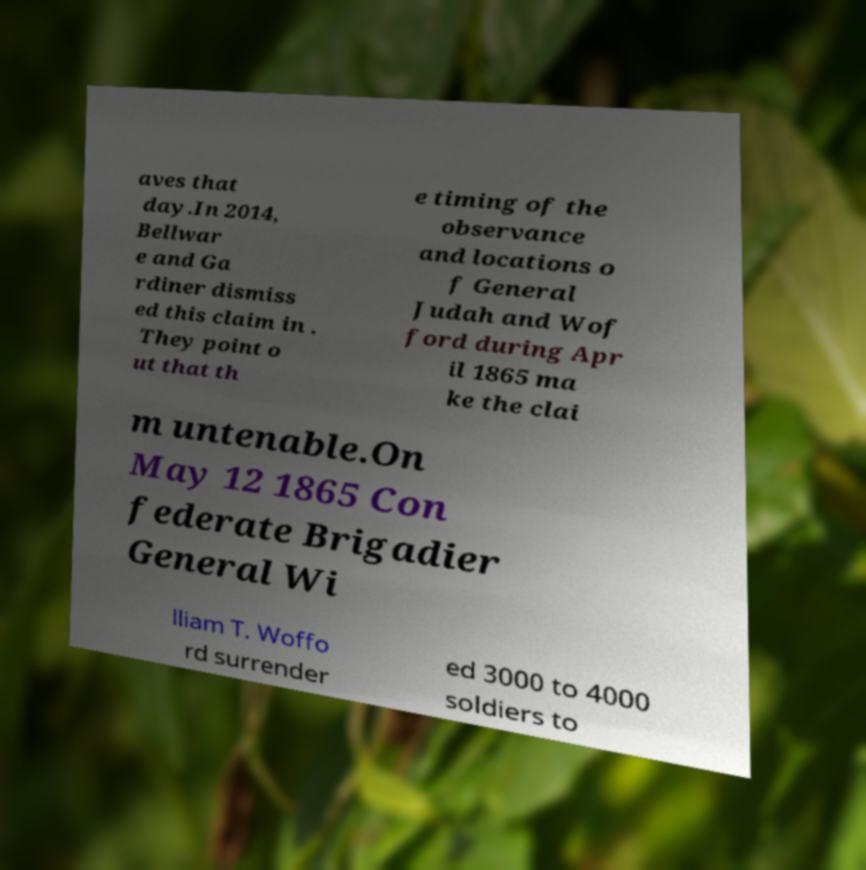There's text embedded in this image that I need extracted. Can you transcribe it verbatim? aves that day.In 2014, Bellwar e and Ga rdiner dismiss ed this claim in . They point o ut that th e timing of the observance and locations o f General Judah and Wof ford during Apr il 1865 ma ke the clai m untenable.On May 12 1865 Con federate Brigadier General Wi lliam T. Woffo rd surrender ed 3000 to 4000 soldiers to 